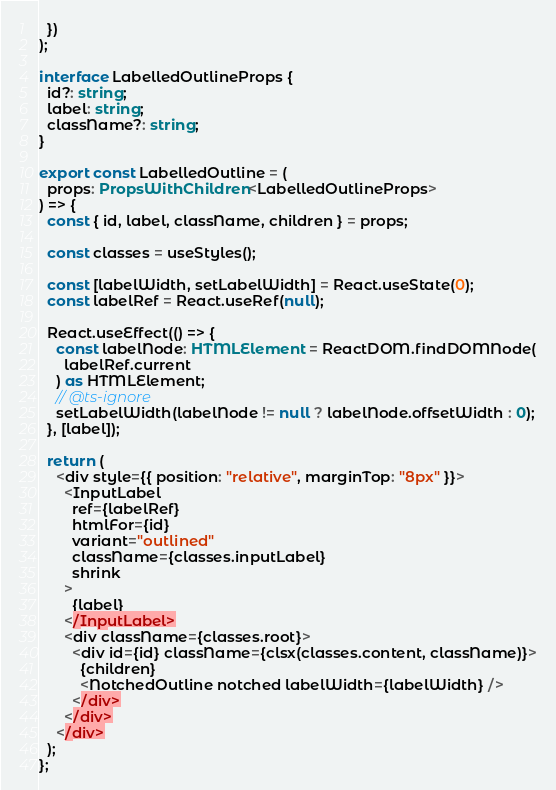Convert code to text. <code><loc_0><loc_0><loc_500><loc_500><_TypeScript_>  })
);

interface LabelledOutlineProps {
  id?: string;
  label: string;
  className?: string;
}

export const LabelledOutline = (
  props: PropsWithChildren<LabelledOutlineProps>
) => {
  const { id, label, className, children } = props;

  const classes = useStyles();

  const [labelWidth, setLabelWidth] = React.useState(0);
  const labelRef = React.useRef(null);

  React.useEffect(() => {
    const labelNode: HTMLElement = ReactDOM.findDOMNode(
      labelRef.current
    ) as HTMLElement;
    // @ts-ignore
    setLabelWidth(labelNode != null ? labelNode.offsetWidth : 0);
  }, [label]);

  return (
    <div style={{ position: "relative", marginTop: "8px" }}>
      <InputLabel
        ref={labelRef}
        htmlFor={id}
        variant="outlined"
        className={classes.inputLabel}
        shrink
      >
        {label}
      </InputLabel>
      <div className={classes.root}>
        <div id={id} className={clsx(classes.content, className)}>
          {children}
          <NotchedOutline notched labelWidth={labelWidth} />
        </div>
      </div>
    </div>
  );
};
</code> 